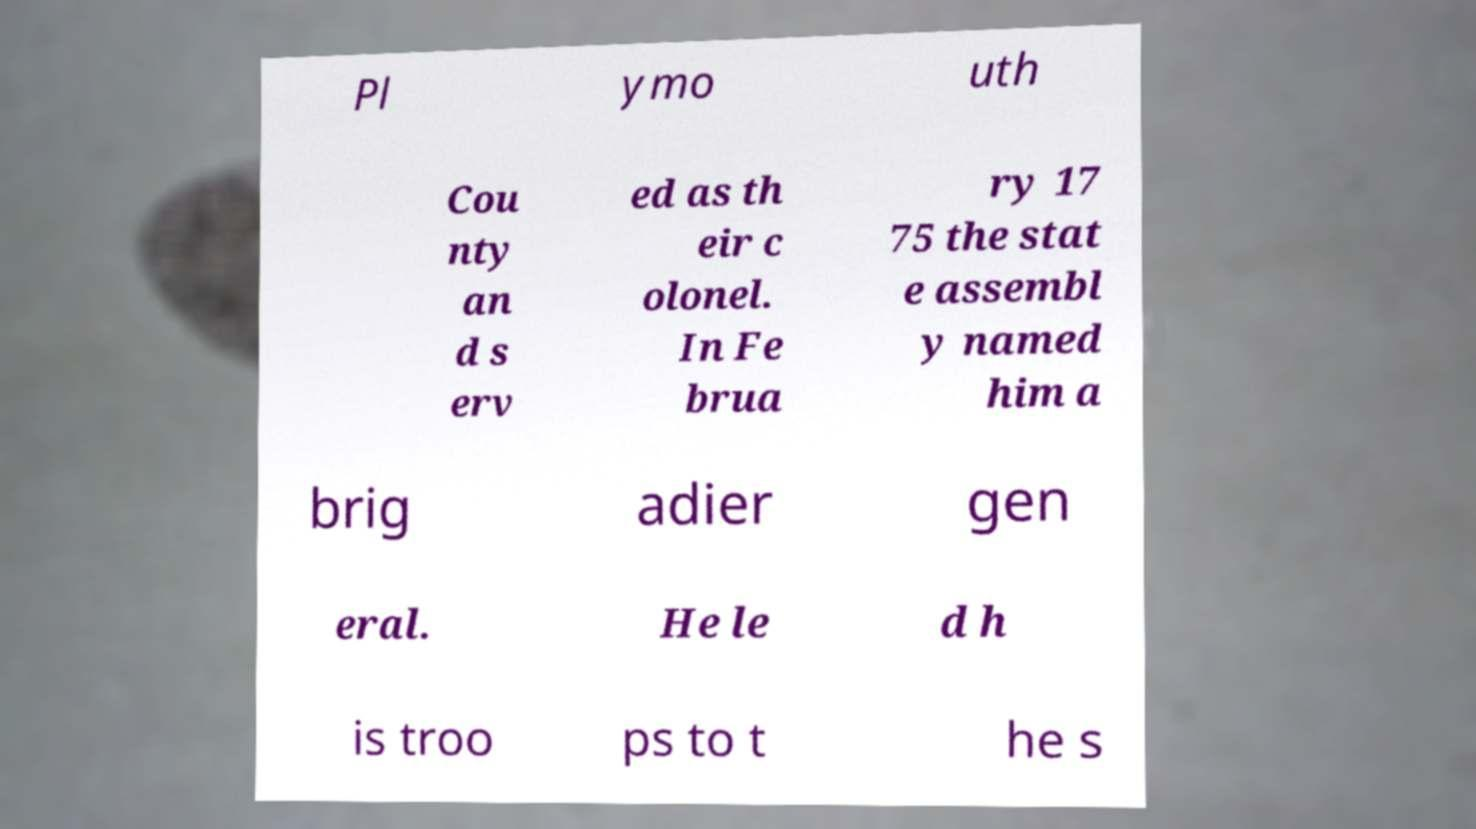There's text embedded in this image that I need extracted. Can you transcribe it verbatim? Pl ymo uth Cou nty an d s erv ed as th eir c olonel. In Fe brua ry 17 75 the stat e assembl y named him a brig adier gen eral. He le d h is troo ps to t he s 